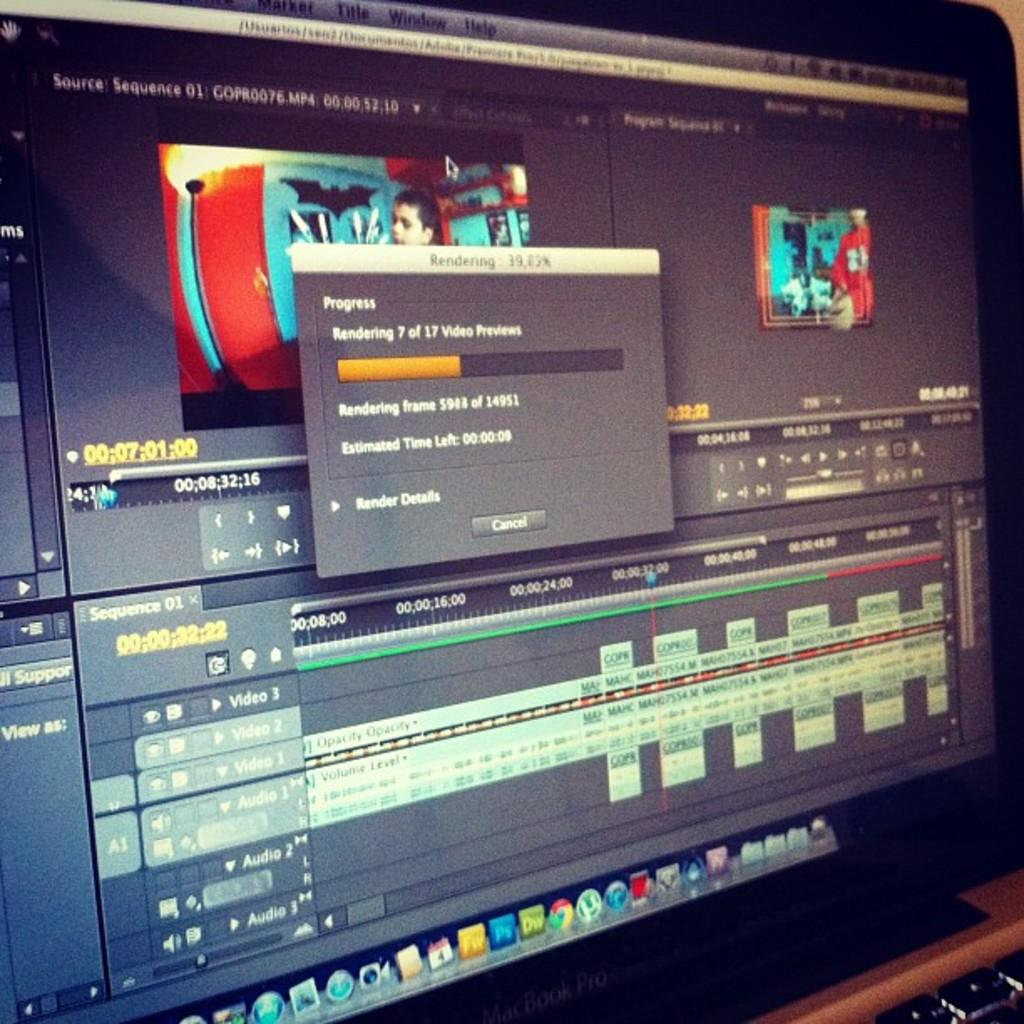<image>
Share a concise interpretation of the image provided. The computer is in the process of rendering number 7 out of 17 videos. 